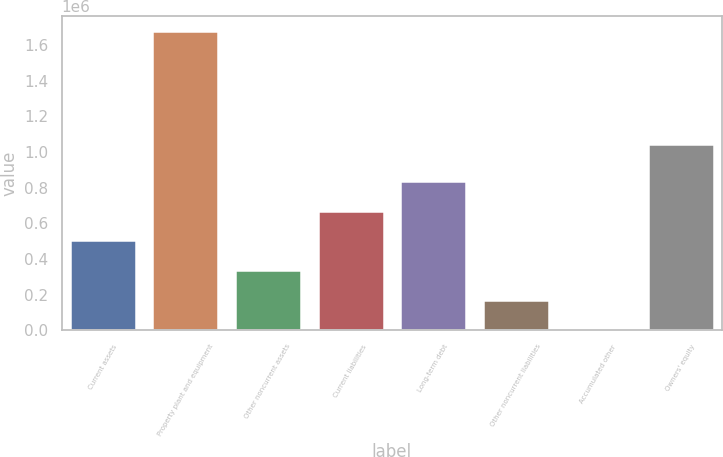<chart> <loc_0><loc_0><loc_500><loc_500><bar_chart><fcel>Current assets<fcel>Property plant and equipment<fcel>Other noncurrent assets<fcel>Current liabilities<fcel>Long-term debt<fcel>Other noncurrent liabilities<fcel>Accumulated other<fcel>Owners' equity<nl><fcel>504114<fcel>1.6781e+06<fcel>336402<fcel>671826<fcel>839538<fcel>168690<fcel>978<fcel>1.04274e+06<nl></chart> 